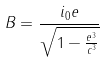Convert formula to latex. <formula><loc_0><loc_0><loc_500><loc_500>B = \frac { i _ { 0 } e } { \sqrt { 1 - \frac { e ^ { 3 } } { c ^ { 3 } } } }</formula> 